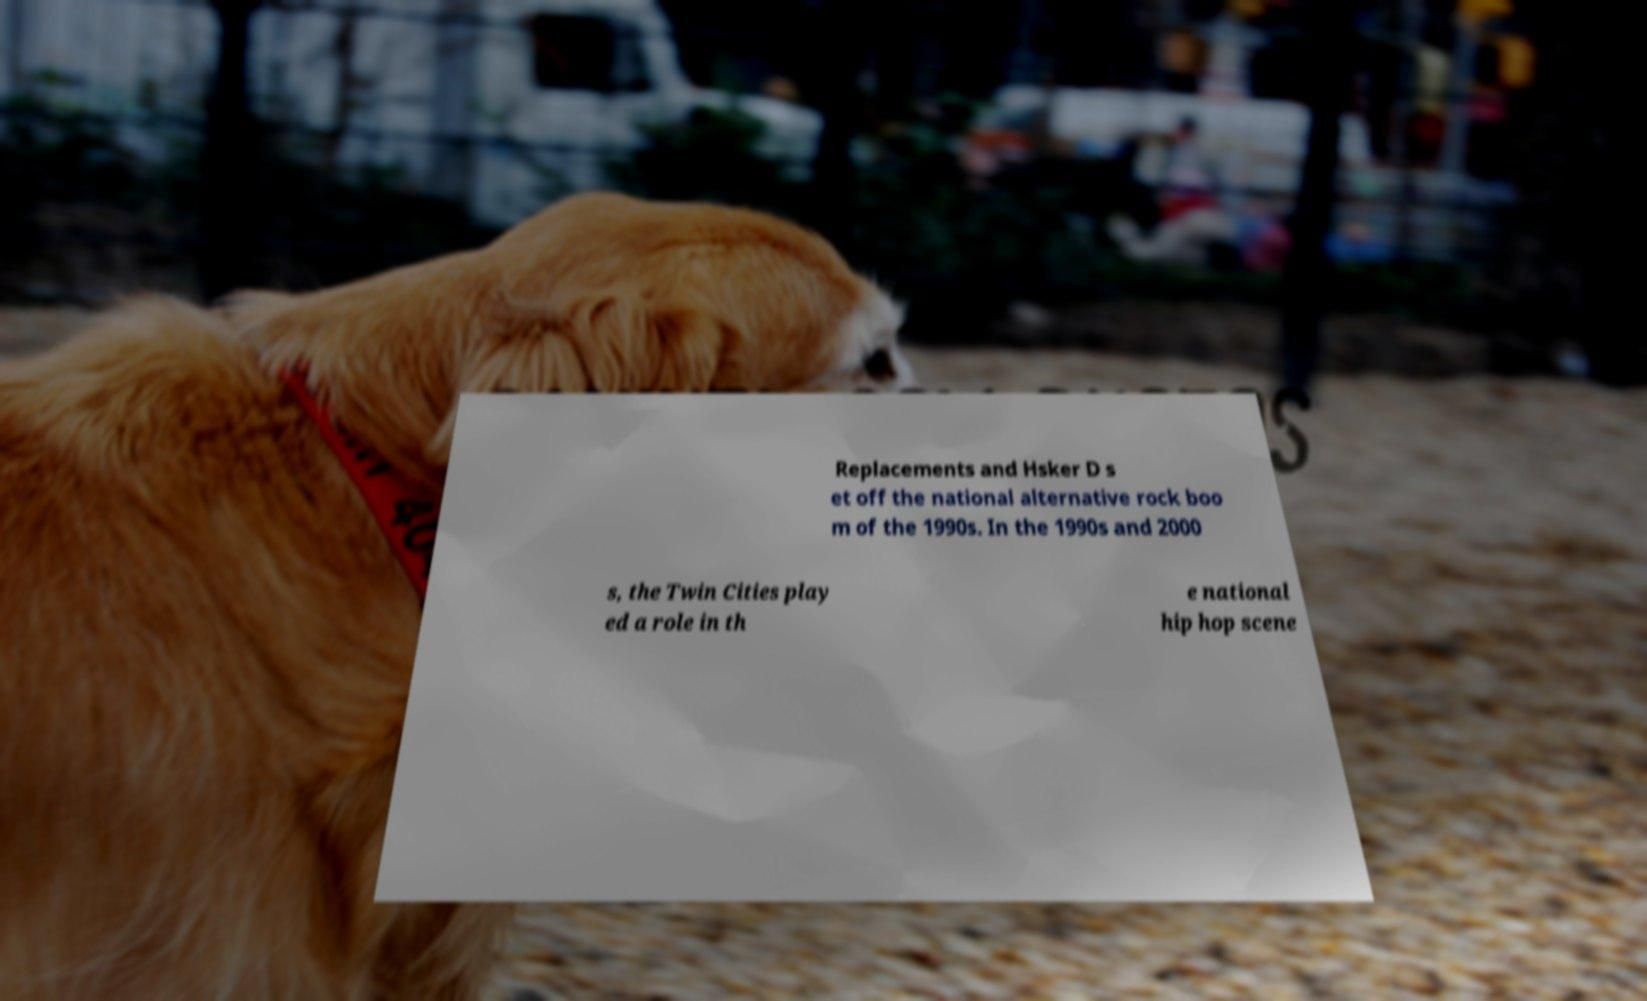Please identify and transcribe the text found in this image. Replacements and Hsker D s et off the national alternative rock boo m of the 1990s. In the 1990s and 2000 s, the Twin Cities play ed a role in th e national hip hop scene 